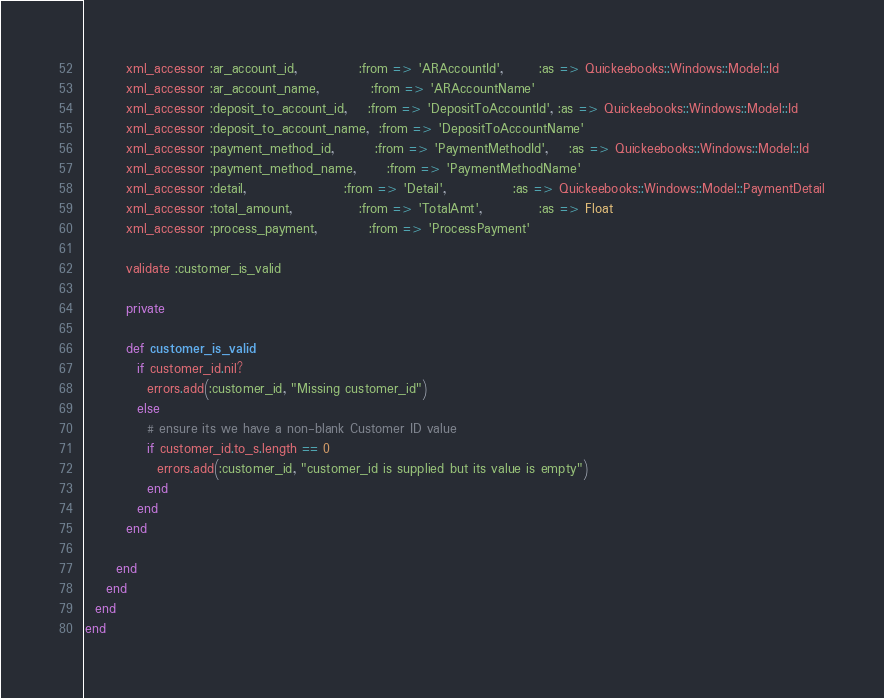Convert code to text. <code><loc_0><loc_0><loc_500><loc_500><_Ruby_>        xml_accessor :ar_account_id,            :from => 'ARAccountId',       :as => Quickeebooks::Windows::Model::Id
        xml_accessor :ar_account_name,          :from => 'ARAccountName'
        xml_accessor :deposit_to_account_id,    :from => 'DepositToAccountId', :as => Quickeebooks::Windows::Model::Id
        xml_accessor :deposit_to_account_name,  :from => 'DepositToAccountName'
        xml_accessor :payment_method_id,        :from => 'PaymentMethodId',    :as => Quickeebooks::Windows::Model::Id
        xml_accessor :payment_method_name,      :from => 'PaymentMethodName'
        xml_accessor :detail,                   :from => 'Detail',             :as => Quickeebooks::Windows::Model::PaymentDetail
        xml_accessor :total_amount,             :from => 'TotalAmt',           :as => Float
        xml_accessor :process_payment,          :from => 'ProcessPayment'
        
        validate :customer_is_valid
        
        private
        
        def customer_is_valid
          if customer_id.nil?
            errors.add(:customer_id, "Missing customer_id")
          else
            # ensure its we have a non-blank Customer ID value
            if customer_id.to_s.length == 0
              errors.add(:customer_id, "customer_id is supplied but its value is empty")
            end
          end
        end
        
      end
    end
  end
end
</code> 